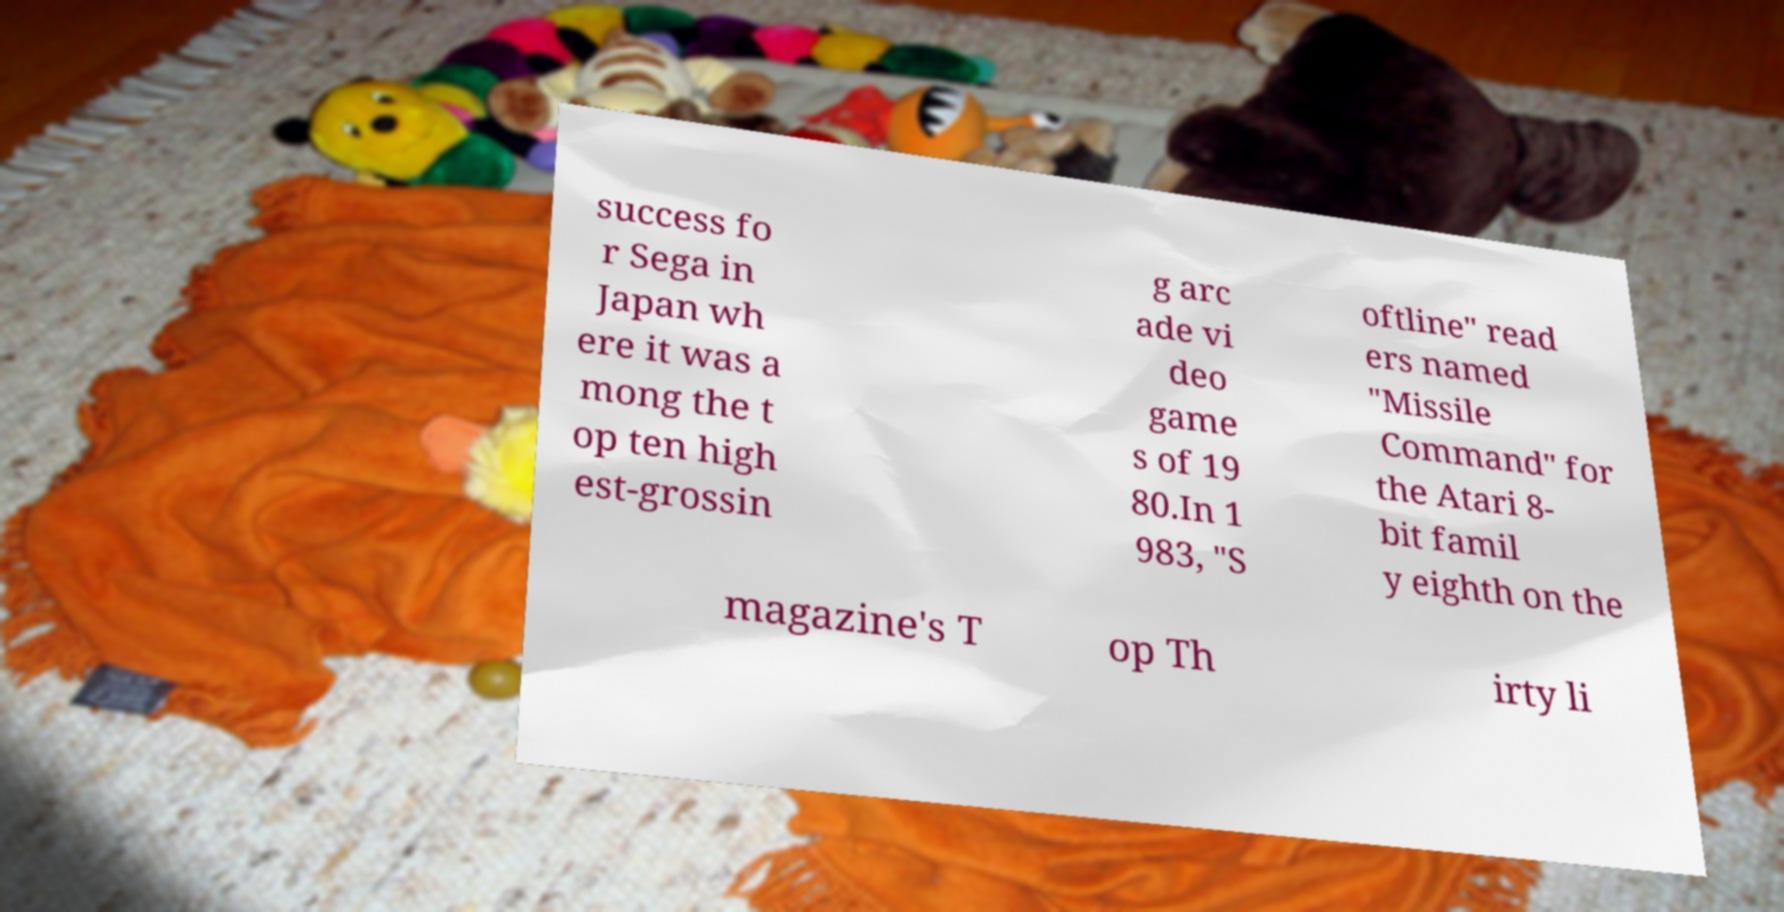Can you accurately transcribe the text from the provided image for me? success fo r Sega in Japan wh ere it was a mong the t op ten high est-grossin g arc ade vi deo game s of 19 80.In 1 983, "S oftline" read ers named "Missile Command" for the Atari 8- bit famil y eighth on the magazine's T op Th irty li 